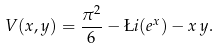<formula> <loc_0><loc_0><loc_500><loc_500>V ( x , y ) = \frac { \pi ^ { 2 } } { 6 } - \L i ( e ^ { x } ) - x \, y .</formula> 